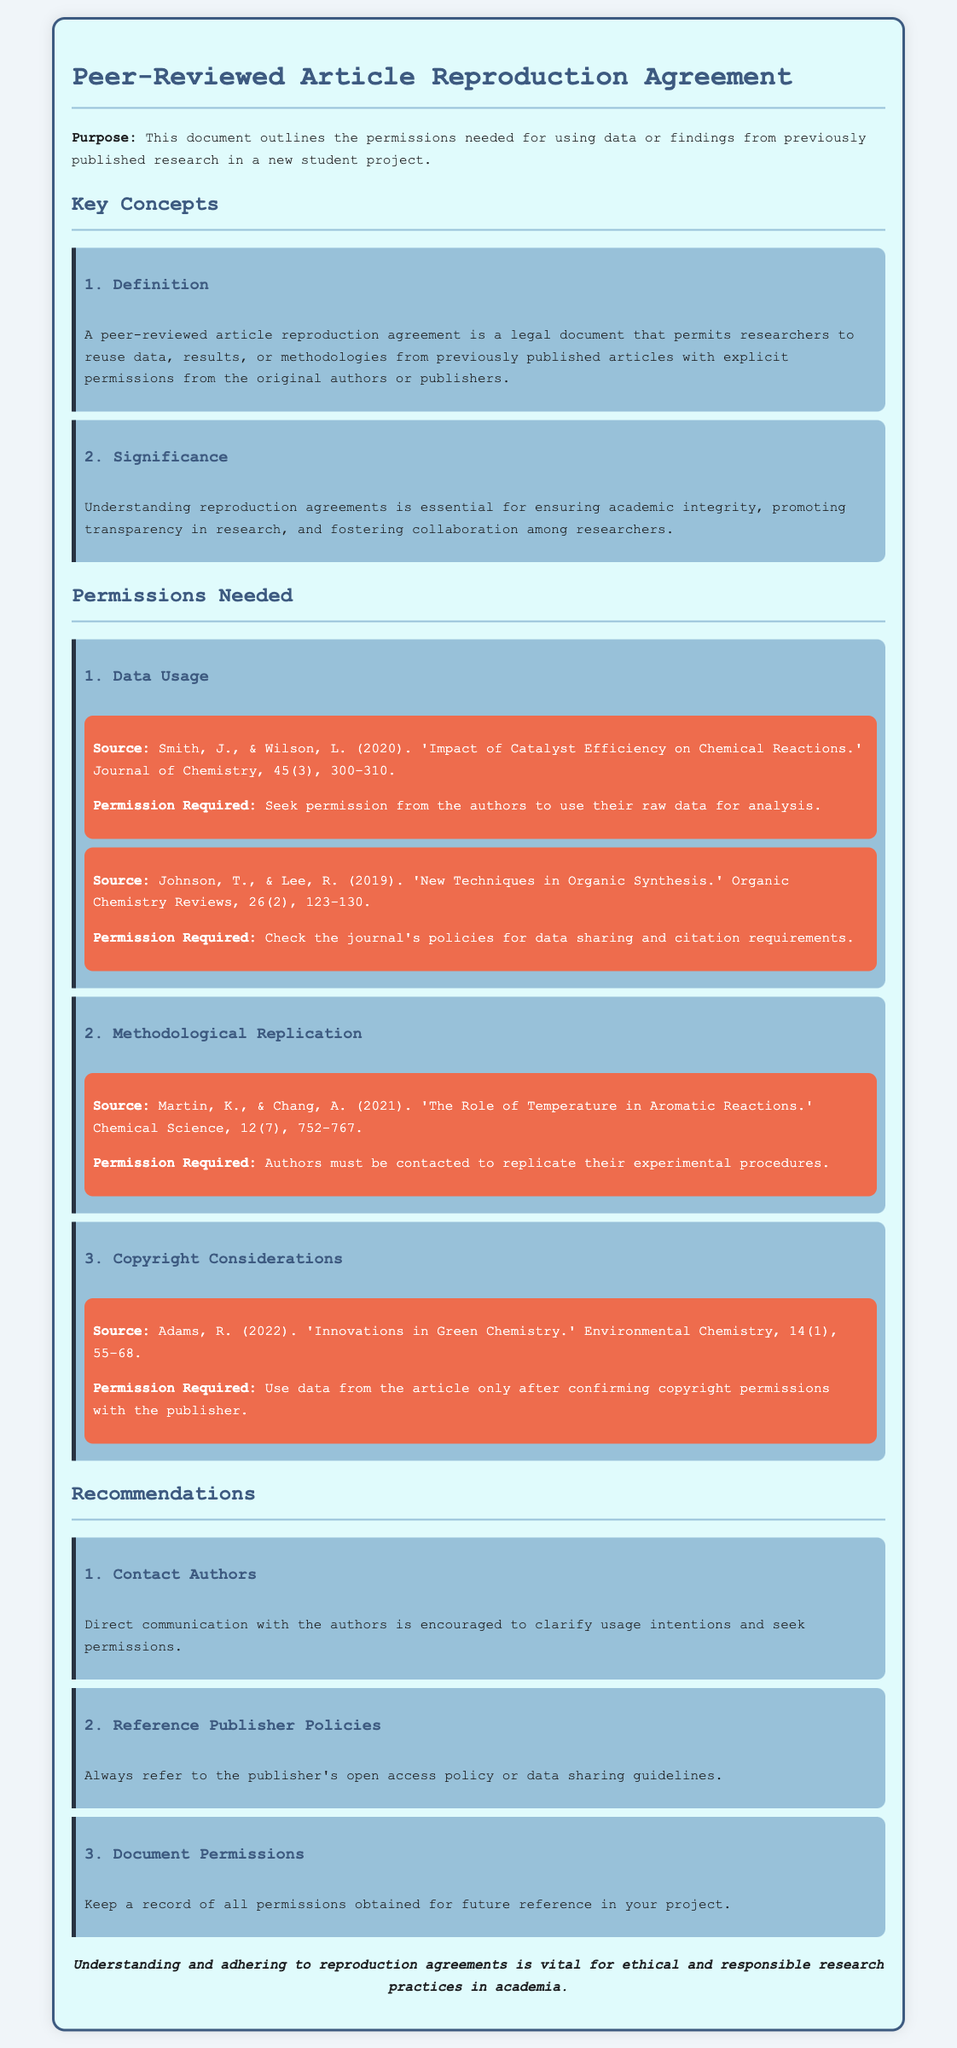What is the purpose of the document? The purpose is explicitly stated in the introduction, outlining the permissions needed for using data or findings from previously published research in a new student project.
Answer: Permissions needed for using data or findings from previously published research in a new student project What must be obtained for data usage? The document specifies that permission must be sought from the authors to use their raw data for analysis.
Answer: Permission from the authors Who is the author of "Innovations in Green Chemistry"? The document lists Adams, R. as the author of this article.
Answer: Adams, R How many categories of permissions are listed? The document outlines three specific categories for permissions needed for use.
Answer: Three What is recommended when contacting authors? The recommendation emphasizes direct communication with the authors is encouraged to clarify usage intentions and seek permissions.
Answer: Direct communication with the authors What is essential for ensuring academic integrity mentioned in the document? The significance section highlights the need for understanding reproduction agreements as essential for ensuring academic integrity.
Answer: Understanding reproduction agreements What should you do after obtaining permissions? The document suggests that you should keep a record of all permissions obtained for future reference in your project.
Answer: Keep a record of all permissions obtained From whom is permission required for methodological replication? The document indicates that authors must be contacted to replicate their experimental procedures.
Answer: Authors What does the conclusion emphasize about reproduction agreements? The conclusion states that understanding and adhering to reproduction agreements is vital for ethical and responsible research practices in academia.
Answer: Vital for ethical and responsible research practices in academia 